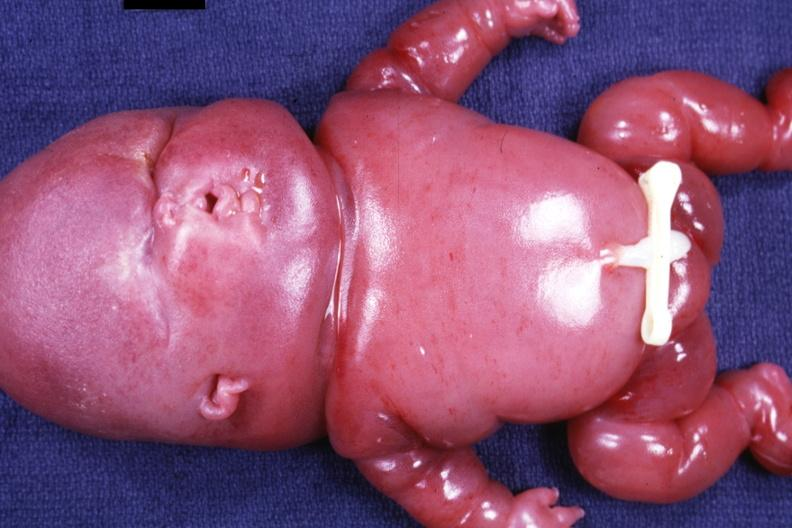does this image show newborn infant 24 week gestation weight gm typical grotesque appearance?
Answer the question using a single word or phrase. Yes 